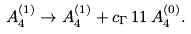Convert formula to latex. <formula><loc_0><loc_0><loc_500><loc_500>A ^ { ( 1 ) } _ { 4 } \to A ^ { ( 1 ) } _ { 4 } + c _ { \Gamma } \, 1 1 \, A ^ { ( 0 ) } _ { 4 } .</formula> 